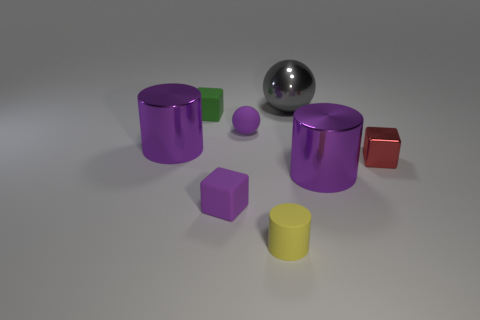Add 6 small purple rubber balls. How many small purple rubber balls exist? 7 Add 1 big gray matte cylinders. How many objects exist? 9 Subtract all purple balls. How many balls are left? 1 Subtract all red blocks. How many blocks are left? 2 Subtract 0 brown blocks. How many objects are left? 8 Subtract all balls. How many objects are left? 6 Subtract 2 cylinders. How many cylinders are left? 1 Subtract all green cubes. Subtract all yellow balls. How many cubes are left? 2 Subtract all yellow balls. How many brown cubes are left? 0 Subtract all purple metal cylinders. Subtract all small matte things. How many objects are left? 2 